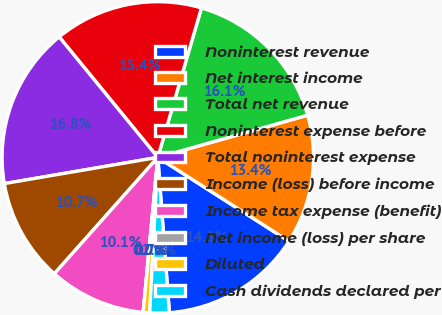Convert chart. <chart><loc_0><loc_0><loc_500><loc_500><pie_chart><fcel>Noninterest revenue<fcel>Net interest income<fcel>Total net revenue<fcel>Noninterest expense before<fcel>Total noninterest expense<fcel>Income (loss) before income<fcel>Income tax expense (benefit)<fcel>Net income (loss) per share<fcel>Diluted<fcel>Cash dividends declared per<nl><fcel>14.77%<fcel>13.42%<fcel>16.11%<fcel>15.44%<fcel>16.78%<fcel>10.74%<fcel>10.07%<fcel>0.0%<fcel>0.67%<fcel>2.01%<nl></chart> 